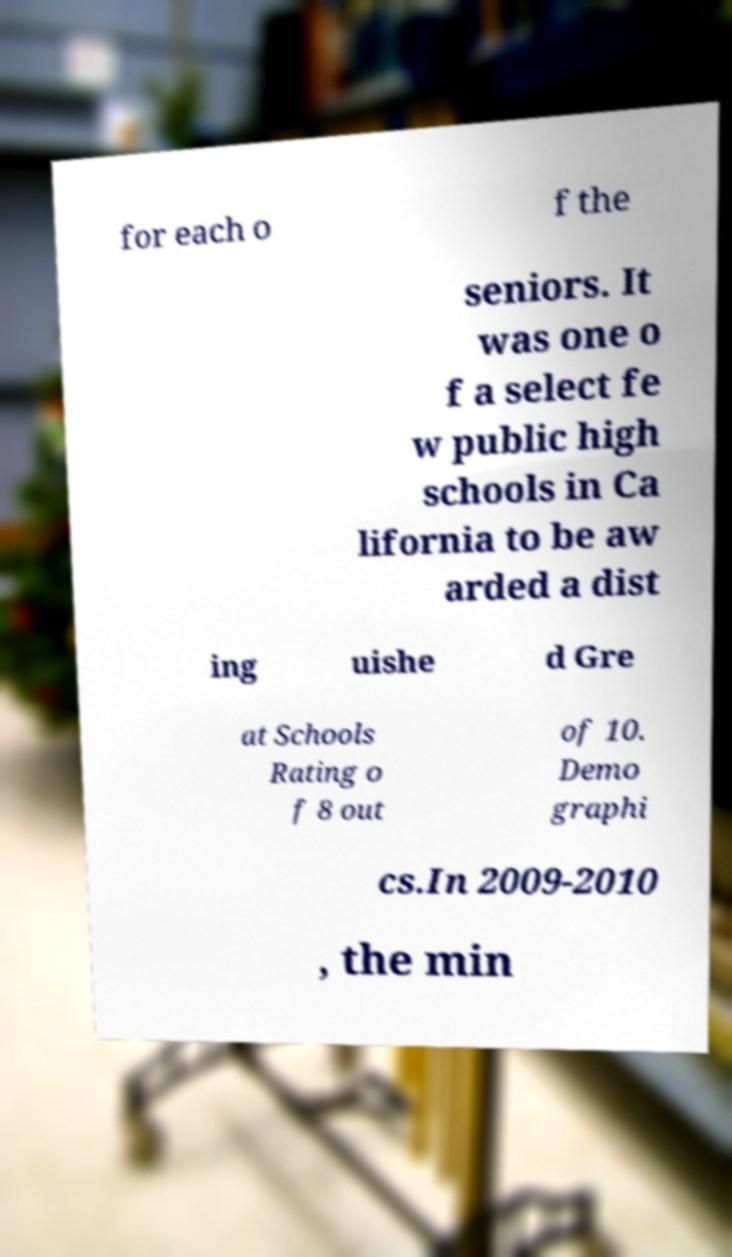Can you accurately transcribe the text from the provided image for me? for each o f the seniors. It was one o f a select fe w public high schools in Ca lifornia to be aw arded a dist ing uishe d Gre at Schools Rating o f 8 out of 10. Demo graphi cs.In 2009-2010 , the min 